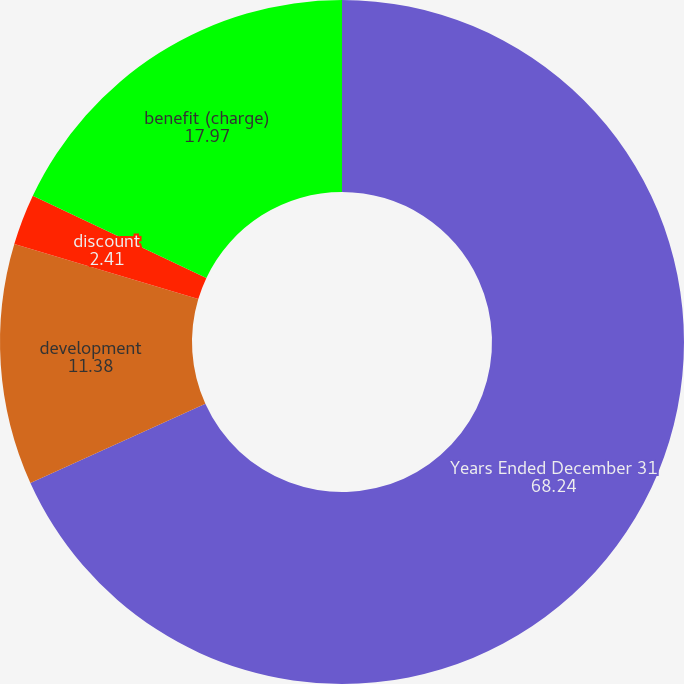<chart> <loc_0><loc_0><loc_500><loc_500><pie_chart><fcel>Years Ended December 31<fcel>development<fcel>discount<fcel>benefit (charge)<nl><fcel>68.24%<fcel>11.38%<fcel>2.41%<fcel>17.97%<nl></chart> 